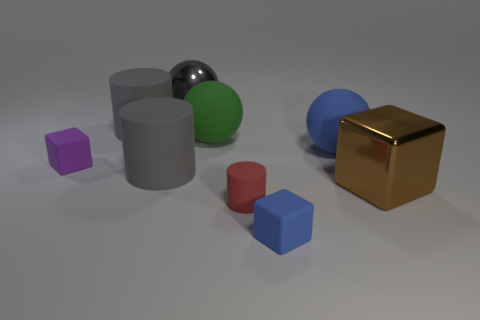Are there any small purple things that have the same material as the red cylinder? Yes, there is a small purple cube that appears to have a matte surface similar to the red cylinder. 